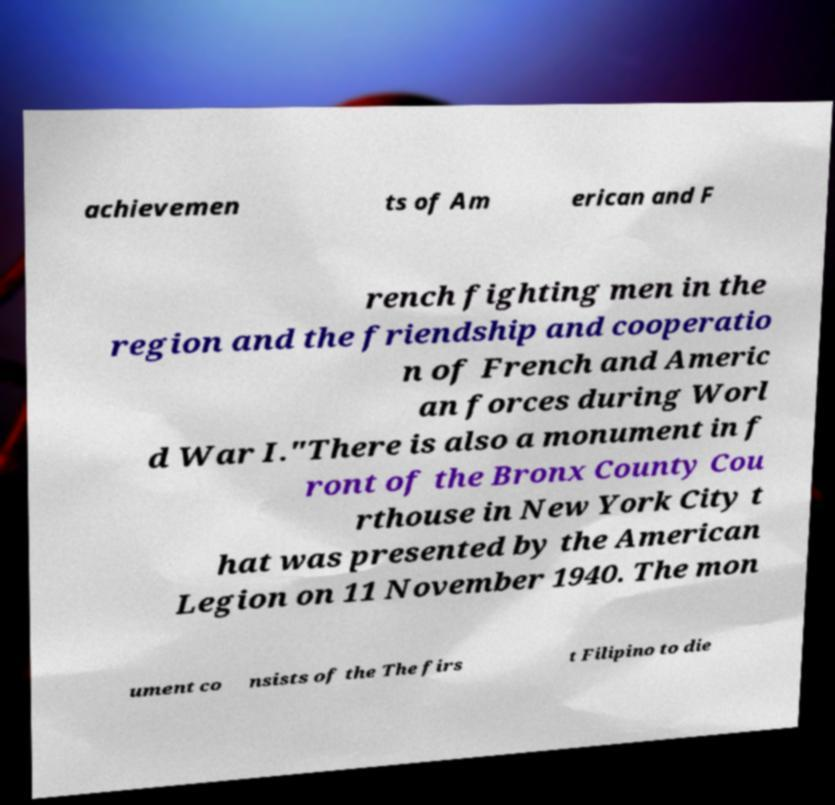Could you extract and type out the text from this image? achievemen ts of Am erican and F rench fighting men in the region and the friendship and cooperatio n of French and Americ an forces during Worl d War I."There is also a monument in f ront of the Bronx County Cou rthouse in New York City t hat was presented by the American Legion on 11 November 1940. The mon ument co nsists of the The firs t Filipino to die 